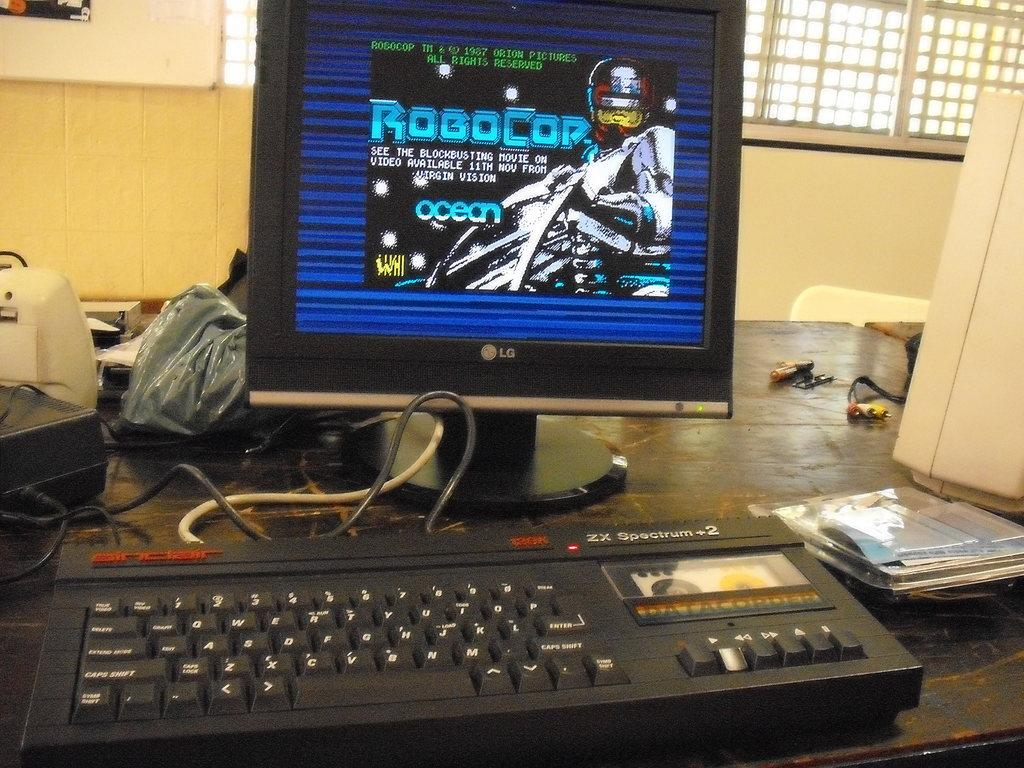<image>
Write a terse but informative summary of the picture. A ZX Spectrum computer with a Robocop game on the monitor 